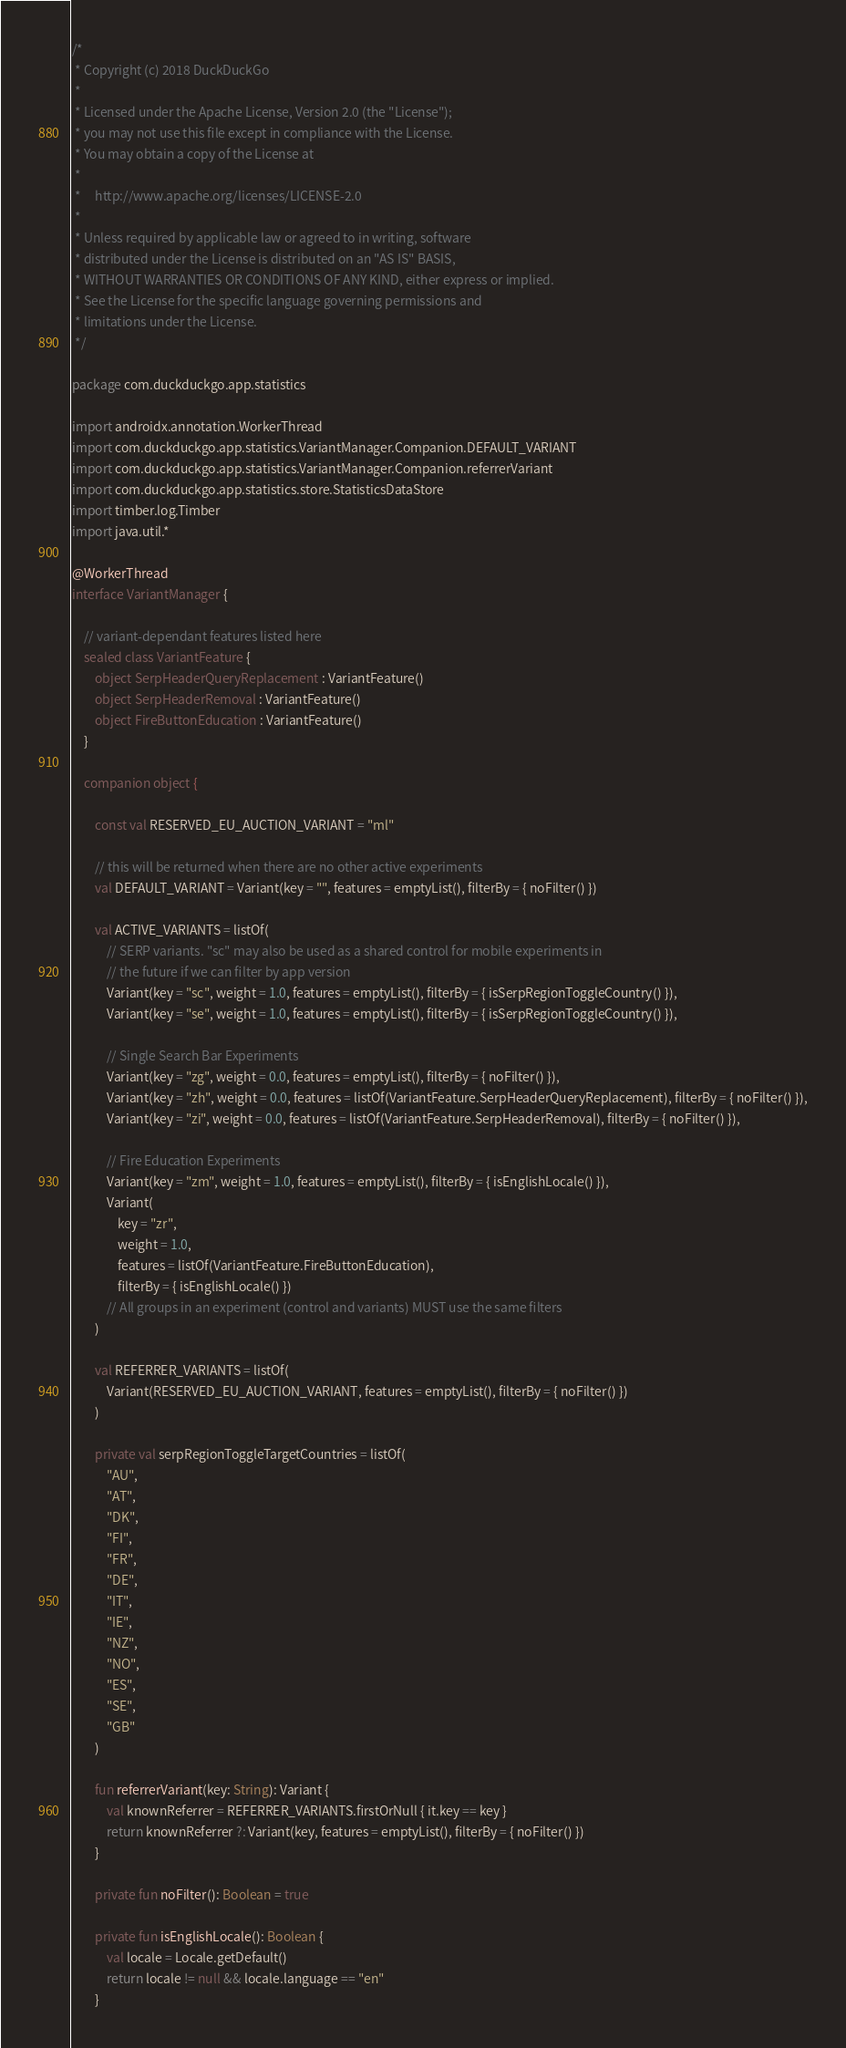Convert code to text. <code><loc_0><loc_0><loc_500><loc_500><_Kotlin_>/*
 * Copyright (c) 2018 DuckDuckGo
 *
 * Licensed under the Apache License, Version 2.0 (the "License");
 * you may not use this file except in compliance with the License.
 * You may obtain a copy of the License at
 *
 *     http://www.apache.org/licenses/LICENSE-2.0
 *
 * Unless required by applicable law or agreed to in writing, software
 * distributed under the License is distributed on an "AS IS" BASIS,
 * WITHOUT WARRANTIES OR CONDITIONS OF ANY KIND, either express or implied.
 * See the License for the specific language governing permissions and
 * limitations under the License.
 */

package com.duckduckgo.app.statistics

import androidx.annotation.WorkerThread
import com.duckduckgo.app.statistics.VariantManager.Companion.DEFAULT_VARIANT
import com.duckduckgo.app.statistics.VariantManager.Companion.referrerVariant
import com.duckduckgo.app.statistics.store.StatisticsDataStore
import timber.log.Timber
import java.util.*

@WorkerThread
interface VariantManager {

    // variant-dependant features listed here
    sealed class VariantFeature {
        object SerpHeaderQueryReplacement : VariantFeature()
        object SerpHeaderRemoval : VariantFeature()
        object FireButtonEducation : VariantFeature()
    }

    companion object {

        const val RESERVED_EU_AUCTION_VARIANT = "ml"

        // this will be returned when there are no other active experiments
        val DEFAULT_VARIANT = Variant(key = "", features = emptyList(), filterBy = { noFilter() })

        val ACTIVE_VARIANTS = listOf(
            // SERP variants. "sc" may also be used as a shared control for mobile experiments in
            // the future if we can filter by app version
            Variant(key = "sc", weight = 1.0, features = emptyList(), filterBy = { isSerpRegionToggleCountry() }),
            Variant(key = "se", weight = 1.0, features = emptyList(), filterBy = { isSerpRegionToggleCountry() }),

            // Single Search Bar Experiments
            Variant(key = "zg", weight = 0.0, features = emptyList(), filterBy = { noFilter() }),
            Variant(key = "zh", weight = 0.0, features = listOf(VariantFeature.SerpHeaderQueryReplacement), filterBy = { noFilter() }),
            Variant(key = "zi", weight = 0.0, features = listOf(VariantFeature.SerpHeaderRemoval), filterBy = { noFilter() }),

            // Fire Education Experiments
            Variant(key = "zm", weight = 1.0, features = emptyList(), filterBy = { isEnglishLocale() }),
            Variant(
                key = "zr",
                weight = 1.0,
                features = listOf(VariantFeature.FireButtonEducation),
                filterBy = { isEnglishLocale() })
            // All groups in an experiment (control and variants) MUST use the same filters
        )

        val REFERRER_VARIANTS = listOf(
            Variant(RESERVED_EU_AUCTION_VARIANT, features = emptyList(), filterBy = { noFilter() })
        )

        private val serpRegionToggleTargetCountries = listOf(
            "AU",
            "AT",
            "DK",
            "FI",
            "FR",
            "DE",
            "IT",
            "IE",
            "NZ",
            "NO",
            "ES",
            "SE",
            "GB"
        )

        fun referrerVariant(key: String): Variant {
            val knownReferrer = REFERRER_VARIANTS.firstOrNull { it.key == key }
            return knownReferrer ?: Variant(key, features = emptyList(), filterBy = { noFilter() })
        }

        private fun noFilter(): Boolean = true

        private fun isEnglishLocale(): Boolean {
            val locale = Locale.getDefault()
            return locale != null && locale.language == "en"
        }
</code> 